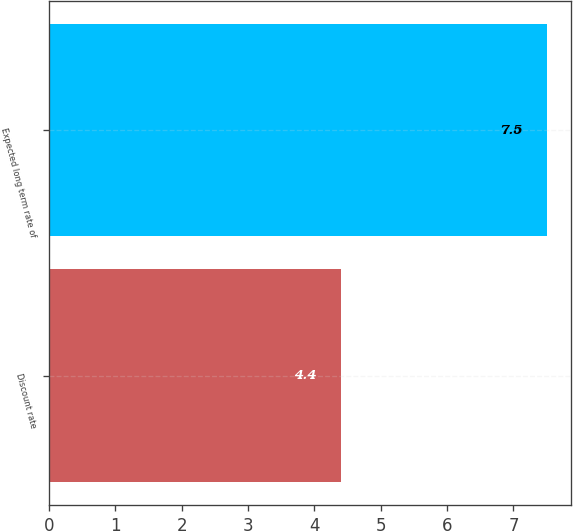Convert chart. <chart><loc_0><loc_0><loc_500><loc_500><bar_chart><fcel>Discount rate<fcel>Expected long term rate of<nl><fcel>4.4<fcel>7.5<nl></chart> 